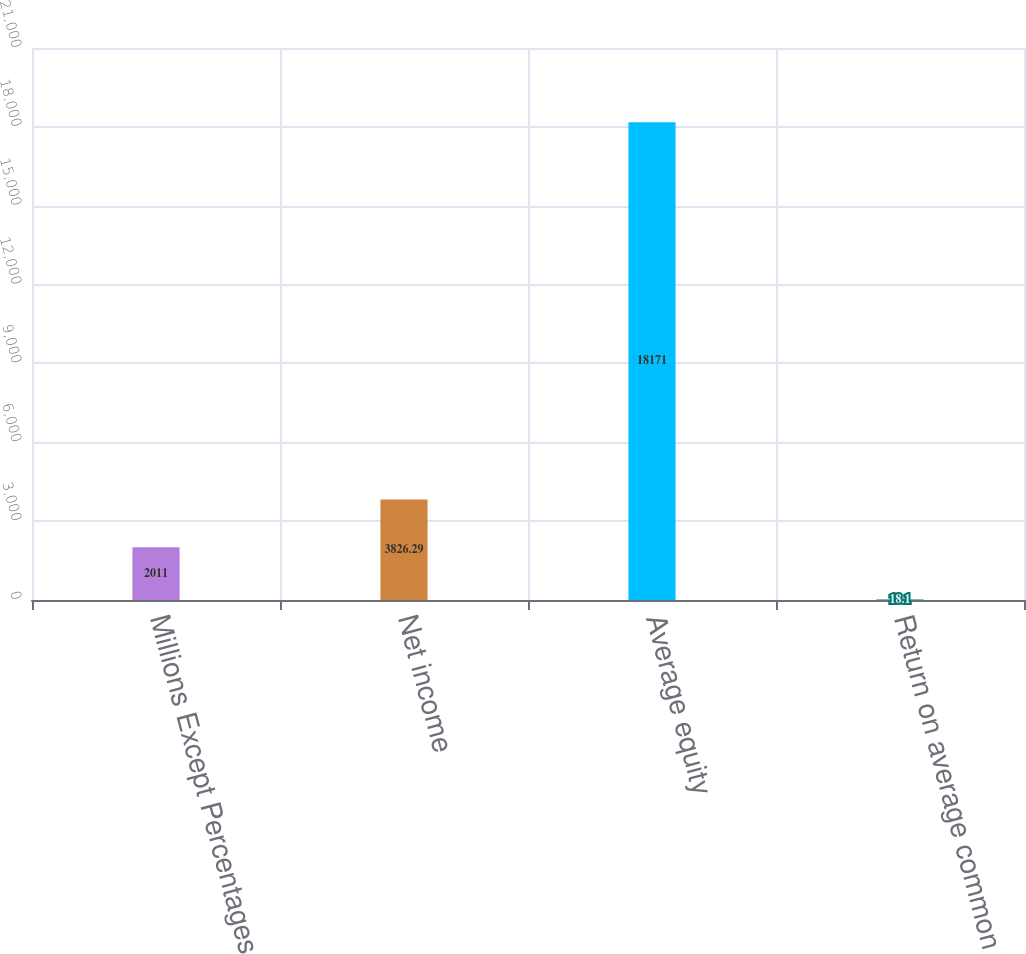<chart> <loc_0><loc_0><loc_500><loc_500><bar_chart><fcel>Millions Except Percentages<fcel>Net income<fcel>Average equity<fcel>Return on average common<nl><fcel>2011<fcel>3826.29<fcel>18171<fcel>18.1<nl></chart> 